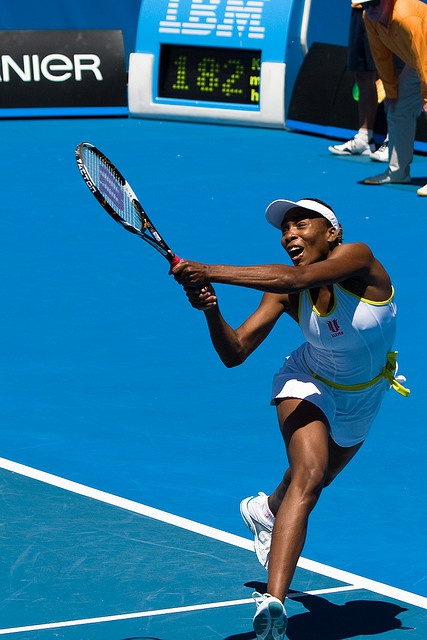Describe the objects in this image and their specific colors. I can see people in blue, black, maroon, and brown tones, people in blue, maroon, black, and darkblue tones, people in blue, black, lightgray, and darkgray tones, and tennis racket in blue, black, lightblue, and gray tones in this image. 